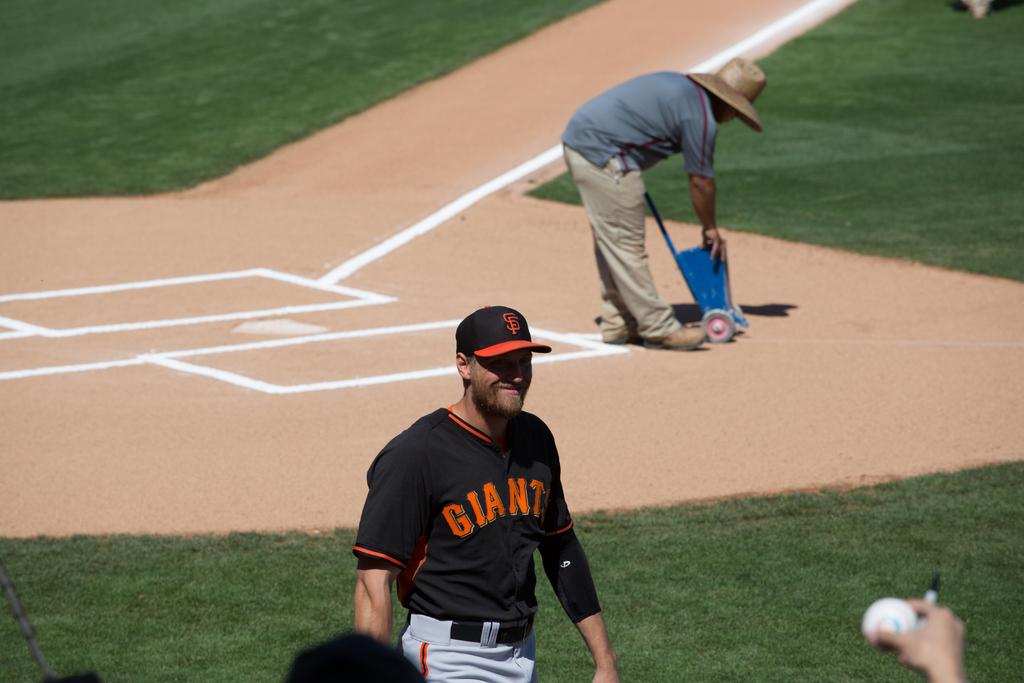What team does this player play for?
Make the answer very short. Giants. 